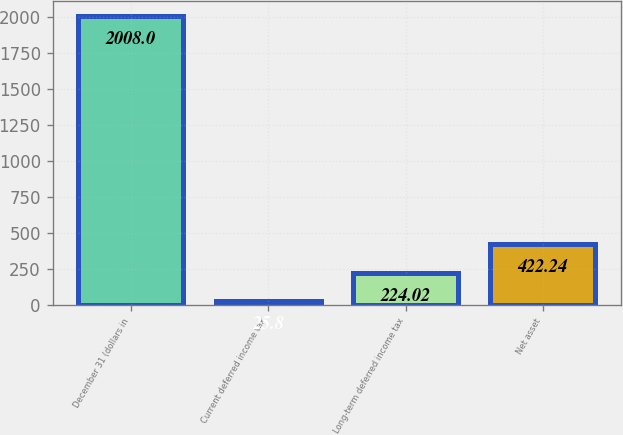<chart> <loc_0><loc_0><loc_500><loc_500><bar_chart><fcel>December 31 (dollars in<fcel>Current deferred income tax<fcel>Long-term deferred income tax<fcel>Net asset<nl><fcel>2008<fcel>25.8<fcel>224.02<fcel>422.24<nl></chart> 